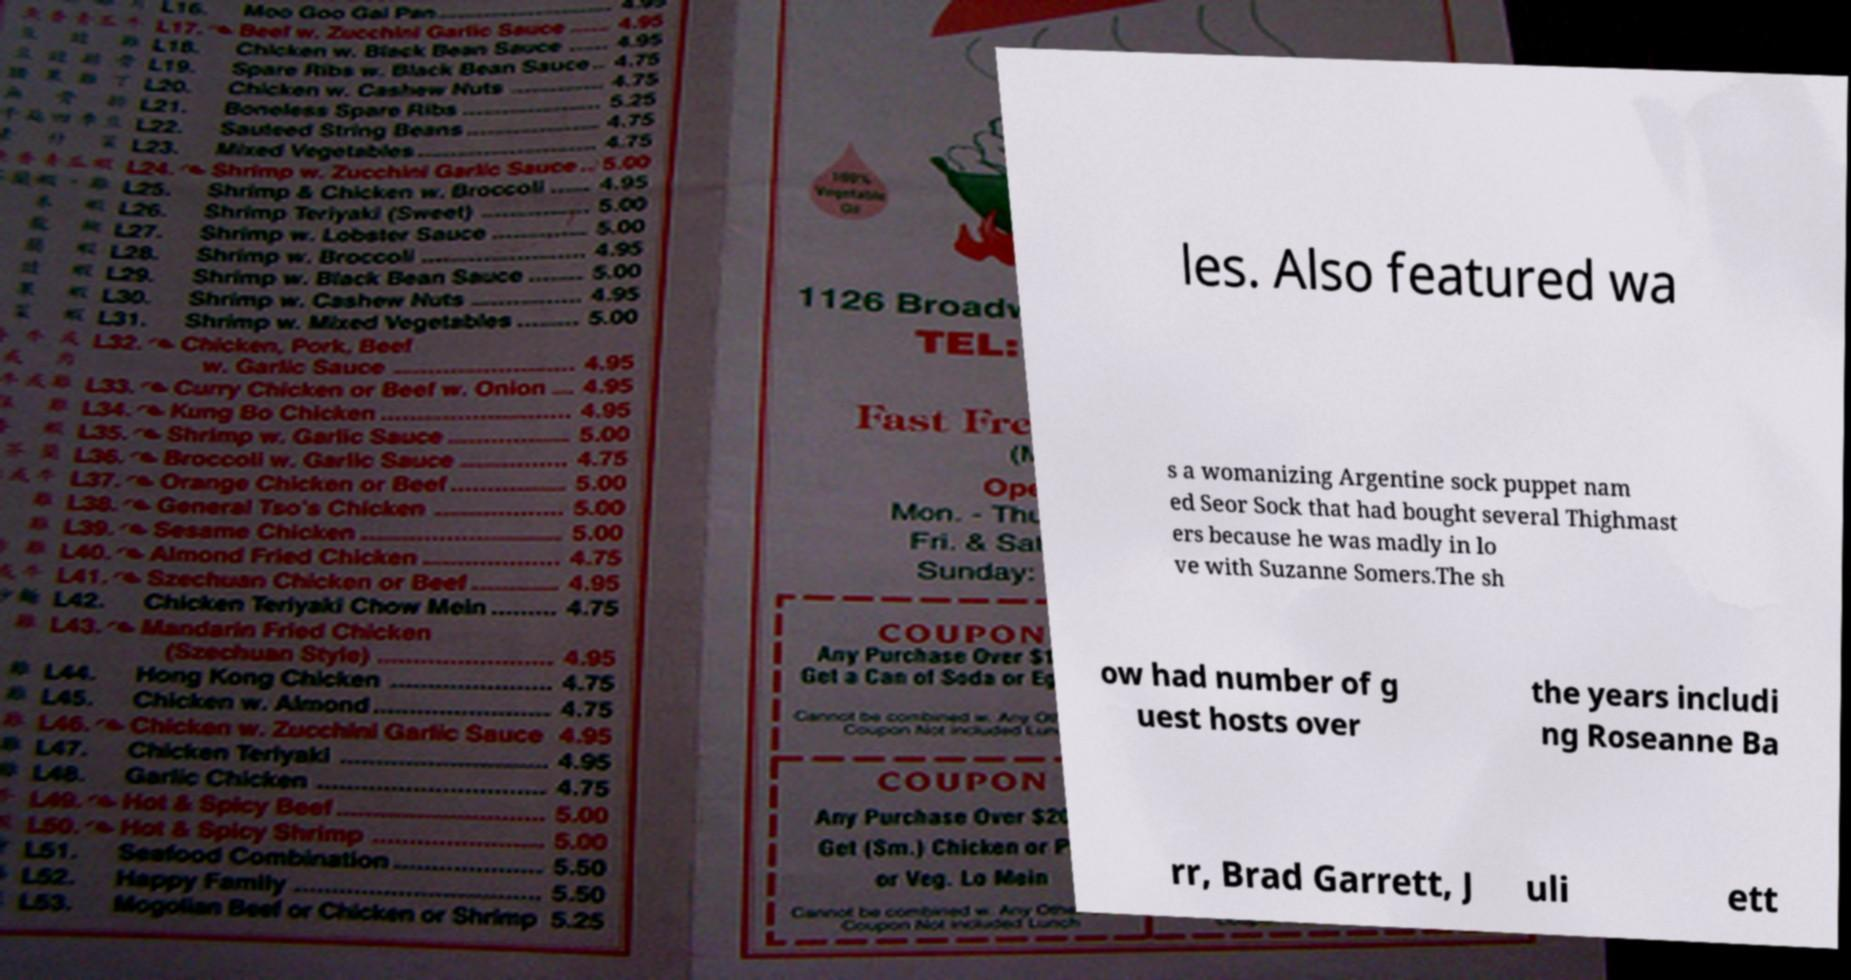Can you read and provide the text displayed in the image?This photo seems to have some interesting text. Can you extract and type it out for me? les. Also featured wa s a womanizing Argentine sock puppet nam ed Seor Sock that had bought several Thighmast ers because he was madly in lo ve with Suzanne Somers.The sh ow had number of g uest hosts over the years includi ng Roseanne Ba rr, Brad Garrett, J uli ett 